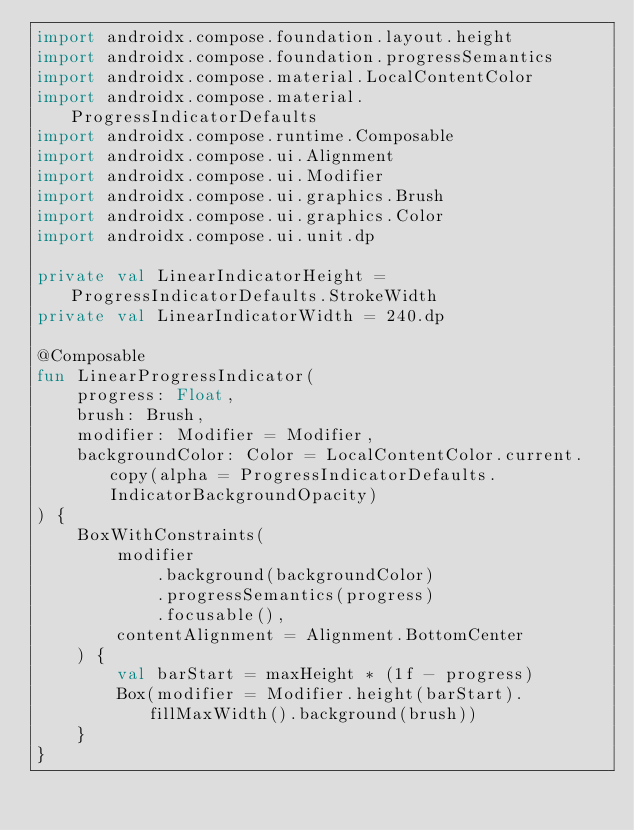Convert code to text. <code><loc_0><loc_0><loc_500><loc_500><_Kotlin_>import androidx.compose.foundation.layout.height
import androidx.compose.foundation.progressSemantics
import androidx.compose.material.LocalContentColor
import androidx.compose.material.ProgressIndicatorDefaults
import androidx.compose.runtime.Composable
import androidx.compose.ui.Alignment
import androidx.compose.ui.Modifier
import androidx.compose.ui.graphics.Brush
import androidx.compose.ui.graphics.Color
import androidx.compose.ui.unit.dp

private val LinearIndicatorHeight = ProgressIndicatorDefaults.StrokeWidth
private val LinearIndicatorWidth = 240.dp

@Composable
fun LinearProgressIndicator(
    progress: Float,
    brush: Brush,
    modifier: Modifier = Modifier,
    backgroundColor: Color = LocalContentColor.current.copy(alpha = ProgressIndicatorDefaults.IndicatorBackgroundOpacity)
) {
    BoxWithConstraints(
        modifier
            .background(backgroundColor)
            .progressSemantics(progress)
            .focusable(),
        contentAlignment = Alignment.BottomCenter
    ) {
        val barStart = maxHeight * (1f - progress)
        Box(modifier = Modifier.height(barStart).fillMaxWidth().background(brush))
    }
}
</code> 